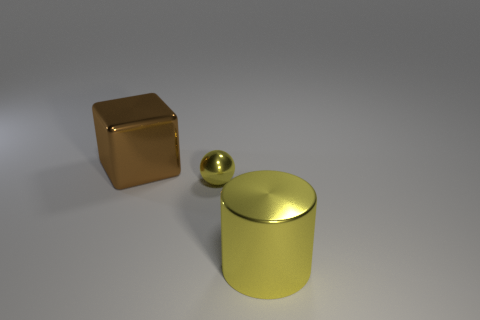There is a big metallic object that is the same color as the metallic ball; what shape is it?
Your answer should be compact. Cylinder. What size is the thing that is the same color as the metallic ball?
Offer a terse response. Large. How many cyan shiny things are there?
Offer a terse response. 0. Do the yellow metal ball and the cylinder have the same size?
Keep it short and to the point. No. How many other objects are there of the same shape as the big yellow metal thing?
Your answer should be very brief. 0. There is a large object that is in front of the big metal object that is left of the large yellow cylinder; what is its material?
Ensure brevity in your answer.  Metal. Are there any metal blocks in front of the brown metal block?
Make the answer very short. No. Is the size of the sphere the same as the yellow shiny object to the right of the tiny yellow metal thing?
Ensure brevity in your answer.  No. There is a yellow thing that is in front of the tiny yellow metallic ball; is its size the same as the yellow metal object that is behind the large yellow metallic cylinder?
Offer a terse response. No. How many small things are either gray matte spheres or brown shiny objects?
Your answer should be compact. 0. 